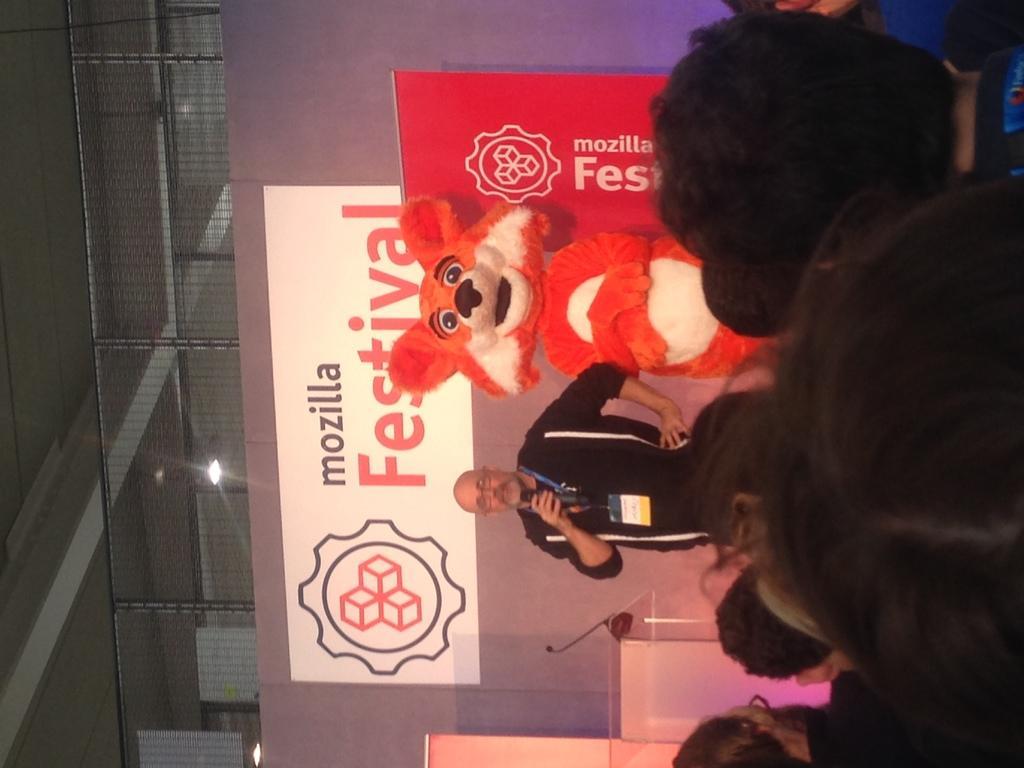Please provide a concise description of this image. In the center of the image there is a person holding a mic. At the bottom of the image there are people. In the background of the image there is a banner. At the top of the image there is a ceiling with fence. There is a depiction of a animal in the center. 